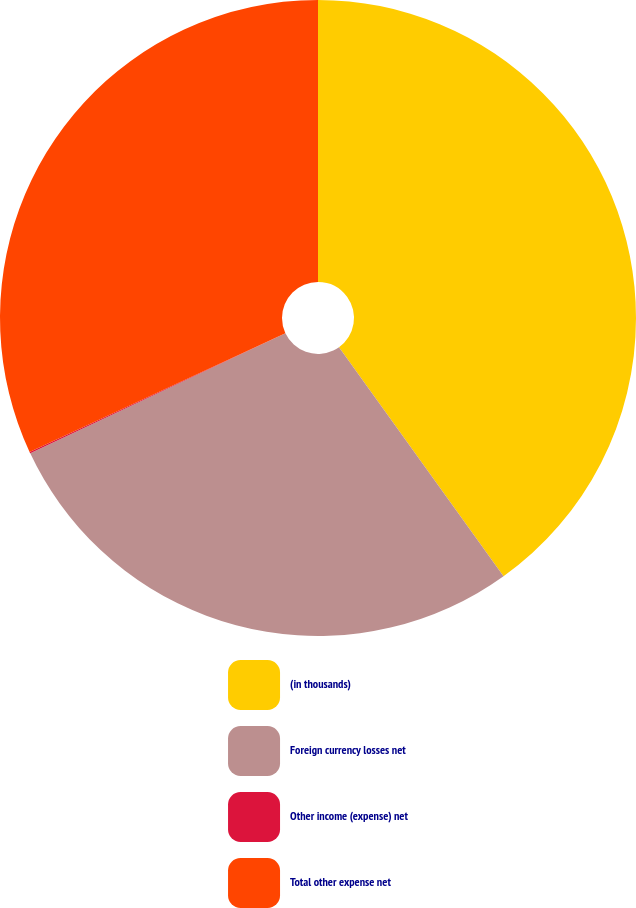Convert chart to OTSL. <chart><loc_0><loc_0><loc_500><loc_500><pie_chart><fcel>(in thousands)<fcel>Foreign currency losses net<fcel>Other income (expense) net<fcel>Total other expense net<nl><fcel>40.09%<fcel>27.92%<fcel>0.08%<fcel>31.92%<nl></chart> 